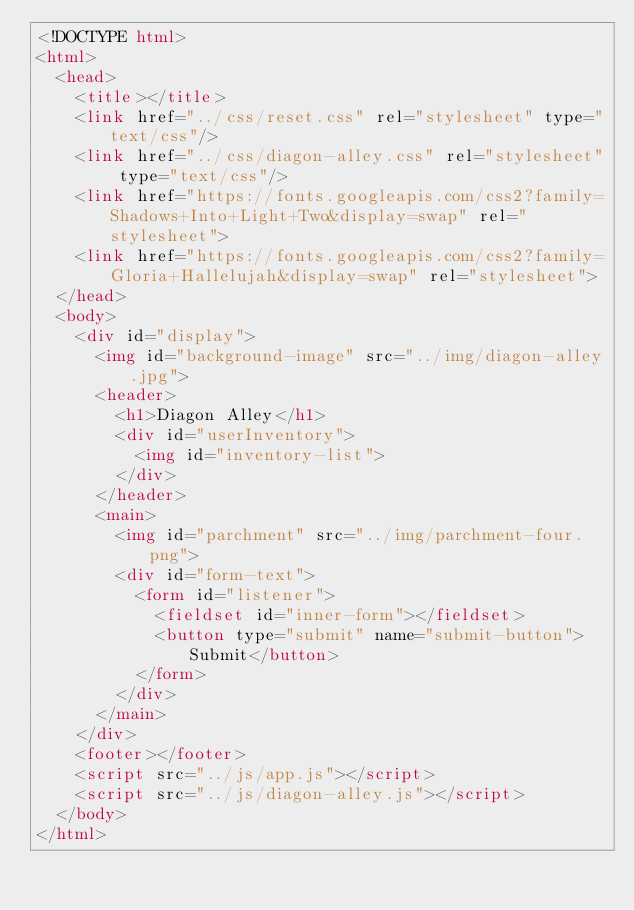<code> <loc_0><loc_0><loc_500><loc_500><_HTML_><!DOCTYPE html>
<html>
  <head>
    <title></title>
    <link href="../css/reset.css" rel="stylesheet" type="text/css"/>
    <link href="../css/diagon-alley.css" rel="stylesheet" type="text/css"/>
    <link href="https://fonts.googleapis.com/css2?family=Shadows+Into+Light+Two&display=swap" rel="stylesheet">
    <link href="https://fonts.googleapis.com/css2?family=Gloria+Hallelujah&display=swap" rel="stylesheet">
  </head>
  <body>
    <div id="display">
      <img id="background-image" src="../img/diagon-alley.jpg">
      <header>
        <h1>Diagon Alley</h1>
        <div id="userInventory">
          <img id="inventory-list">
        </div>
      </header>
      <main>
        <img id="parchment" src="../img/parchment-four.png">
        <div id="form-text">
          <form id="listener">
            <fieldset id="inner-form"></fieldset>
            <button type="submit" name="submit-button">Submit</button>
          </form>
        </div>
      </main>
    </div>
    <footer></footer>
    <script src="../js/app.js"></script>
    <script src="../js/diagon-alley.js"></script>
  </body>
</html>
</code> 